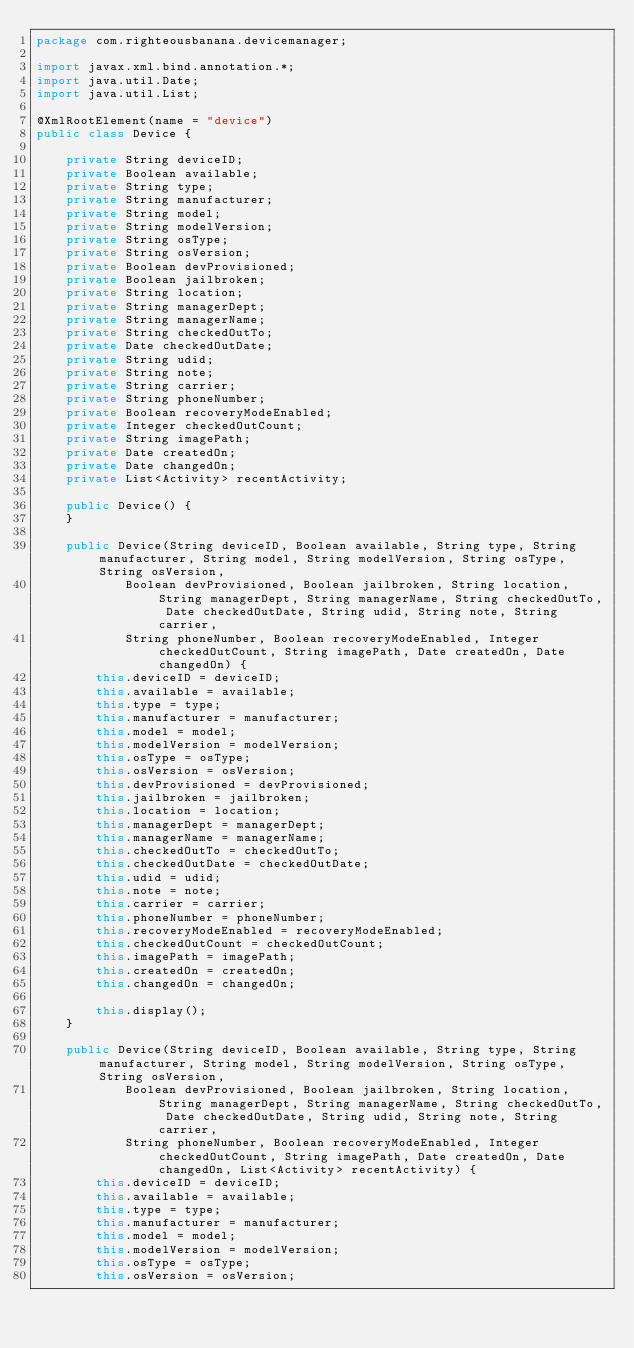Convert code to text. <code><loc_0><loc_0><loc_500><loc_500><_Java_>package com.righteousbanana.devicemanager;

import javax.xml.bind.annotation.*;
import java.util.Date;
import java.util.List;

@XmlRootElement(name = "device")
public class Device {
	
	private String deviceID;
	private Boolean available;
	private String type;
	private String manufacturer;
	private String model;
	private String modelVersion;
	private String osType;
	private String osVersion;
	private Boolean devProvisioned;
	private Boolean jailbroken;
	private String location;
	private String managerDept;
	private String managerName;
	private String checkedOutTo;
	private Date checkedOutDate;
	private String udid;
	private String note;
	private String carrier;
	private String phoneNumber;
	private Boolean recoveryModeEnabled;
	private Integer checkedOutCount;
	private String imagePath;
	private Date createdOn;
	private Date changedOn;
	private List<Activity> recentActivity;
	
	public Device() {
	}
	
	public Device(String deviceID, Boolean available, String type, String manufacturer, String model, String modelVersion, String osType, String osVersion, 
			Boolean devProvisioned, Boolean jailbroken, String location, String managerDept, String managerName, String checkedOutTo, Date checkedOutDate, String udid, String note, String carrier, 
			String phoneNumber, Boolean recoveryModeEnabled, Integer checkedOutCount, String imagePath, Date createdOn, Date changedOn) {
		this.deviceID = deviceID;
		this.available = available;
		this.type = type;
		this.manufacturer = manufacturer;
		this.model = model;
		this.modelVersion = modelVersion;
		this.osType = osType;
		this.osVersion = osVersion;
		this.devProvisioned = devProvisioned;
		this.jailbroken = jailbroken;
		this.location = location;
		this.managerDept = managerDept;
		this.managerName = managerName;
		this.checkedOutTo = checkedOutTo;
		this.checkedOutDate = checkedOutDate;
		this.udid = udid;
		this.note = note;
		this.carrier = carrier;
		this.phoneNumber = phoneNumber;
		this.recoveryModeEnabled = recoveryModeEnabled;
		this.checkedOutCount = checkedOutCount;
		this.imagePath = imagePath;
		this.createdOn = createdOn;
		this.changedOn = changedOn;
		
		this.display();
	}
	
	public Device(String deviceID, Boolean available, String type, String manufacturer, String model, String modelVersion, String osType, String osVersion, 
			Boolean devProvisioned, Boolean jailbroken, String location, String managerDept, String managerName, String checkedOutTo, Date checkedOutDate, String udid, String note, String carrier, 
			String phoneNumber, Boolean recoveryModeEnabled, Integer checkedOutCount, String imagePath, Date createdOn, Date changedOn, List<Activity> recentActivity) {
		this.deviceID = deviceID;
		this.available = available;
		this.type = type;
		this.manufacturer = manufacturer;
		this.model = model;
		this.modelVersion = modelVersion;
		this.osType = osType;
		this.osVersion = osVersion;</code> 